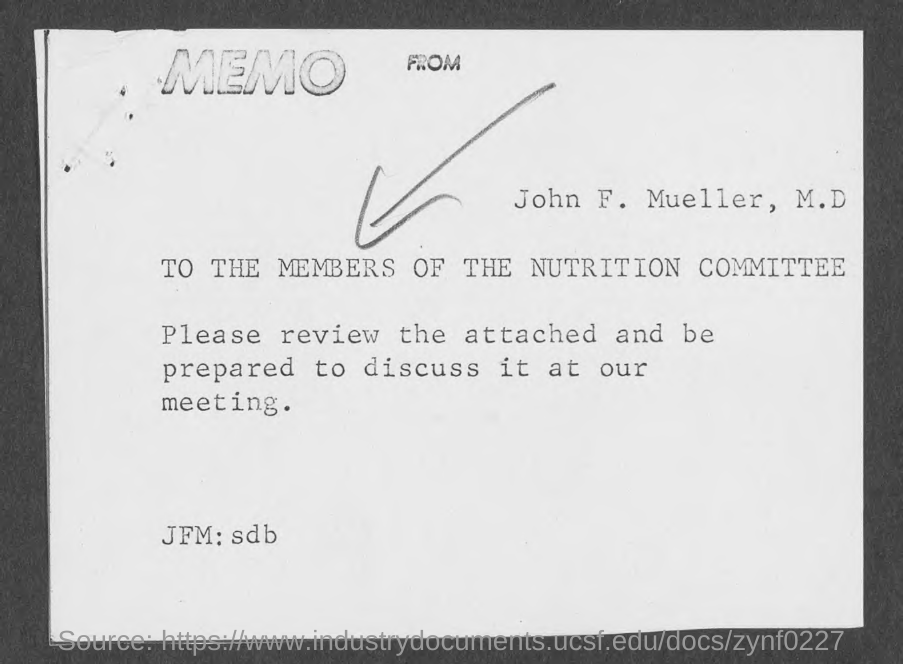To whom is this memo for ?
Offer a very short reply. To the members of the nutrition committee. 